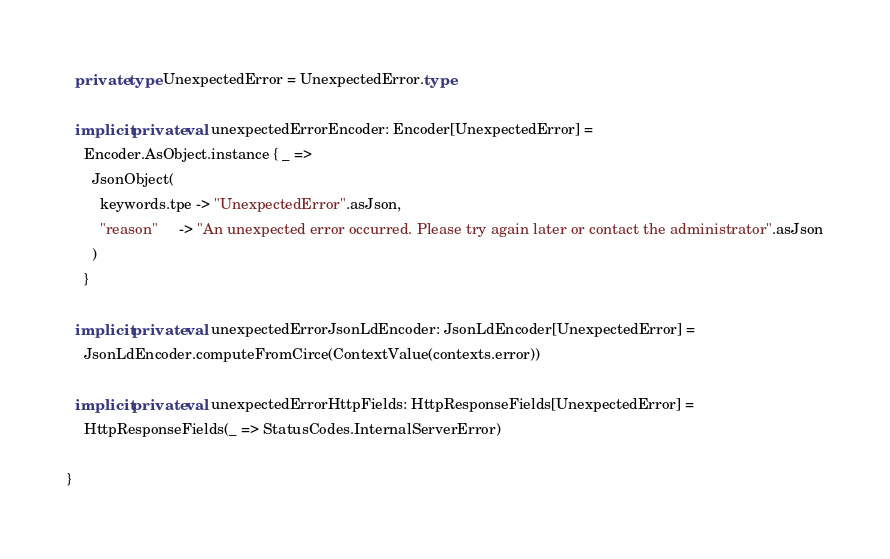Convert code to text. <code><loc_0><loc_0><loc_500><loc_500><_Scala_>  private type UnexpectedError = UnexpectedError.type

  implicit private val unexpectedErrorEncoder: Encoder[UnexpectedError] =
    Encoder.AsObject.instance { _ =>
      JsonObject(
        keywords.tpe -> "UnexpectedError".asJson,
        "reason"     -> "An unexpected error occurred. Please try again later or contact the administrator".asJson
      )
    }

  implicit private val unexpectedErrorJsonLdEncoder: JsonLdEncoder[UnexpectedError] =
    JsonLdEncoder.computeFromCirce(ContextValue(contexts.error))

  implicit private val unexpectedErrorHttpFields: HttpResponseFields[UnexpectedError] =
    HttpResponseFields(_ => StatusCodes.InternalServerError)

}
</code> 